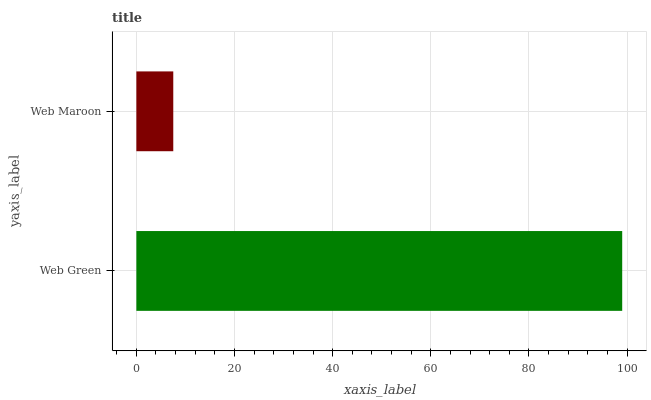Is Web Maroon the minimum?
Answer yes or no. Yes. Is Web Green the maximum?
Answer yes or no. Yes. Is Web Maroon the maximum?
Answer yes or no. No. Is Web Green greater than Web Maroon?
Answer yes or no. Yes. Is Web Maroon less than Web Green?
Answer yes or no. Yes. Is Web Maroon greater than Web Green?
Answer yes or no. No. Is Web Green less than Web Maroon?
Answer yes or no. No. Is Web Green the high median?
Answer yes or no. Yes. Is Web Maroon the low median?
Answer yes or no. Yes. Is Web Maroon the high median?
Answer yes or no. No. Is Web Green the low median?
Answer yes or no. No. 